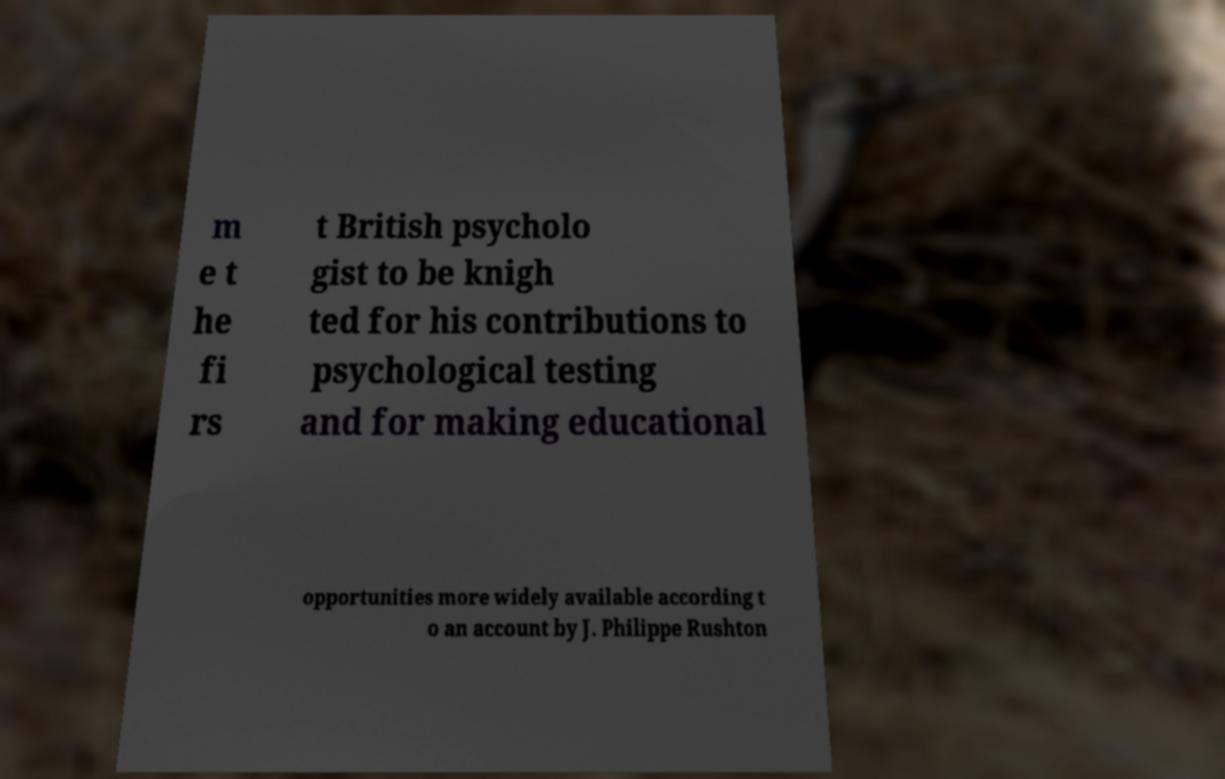Could you assist in decoding the text presented in this image and type it out clearly? m e t he fi rs t British psycholo gist to be knigh ted for his contributions to psychological testing and for making educational opportunities more widely available according t o an account by J. Philippe Rushton 